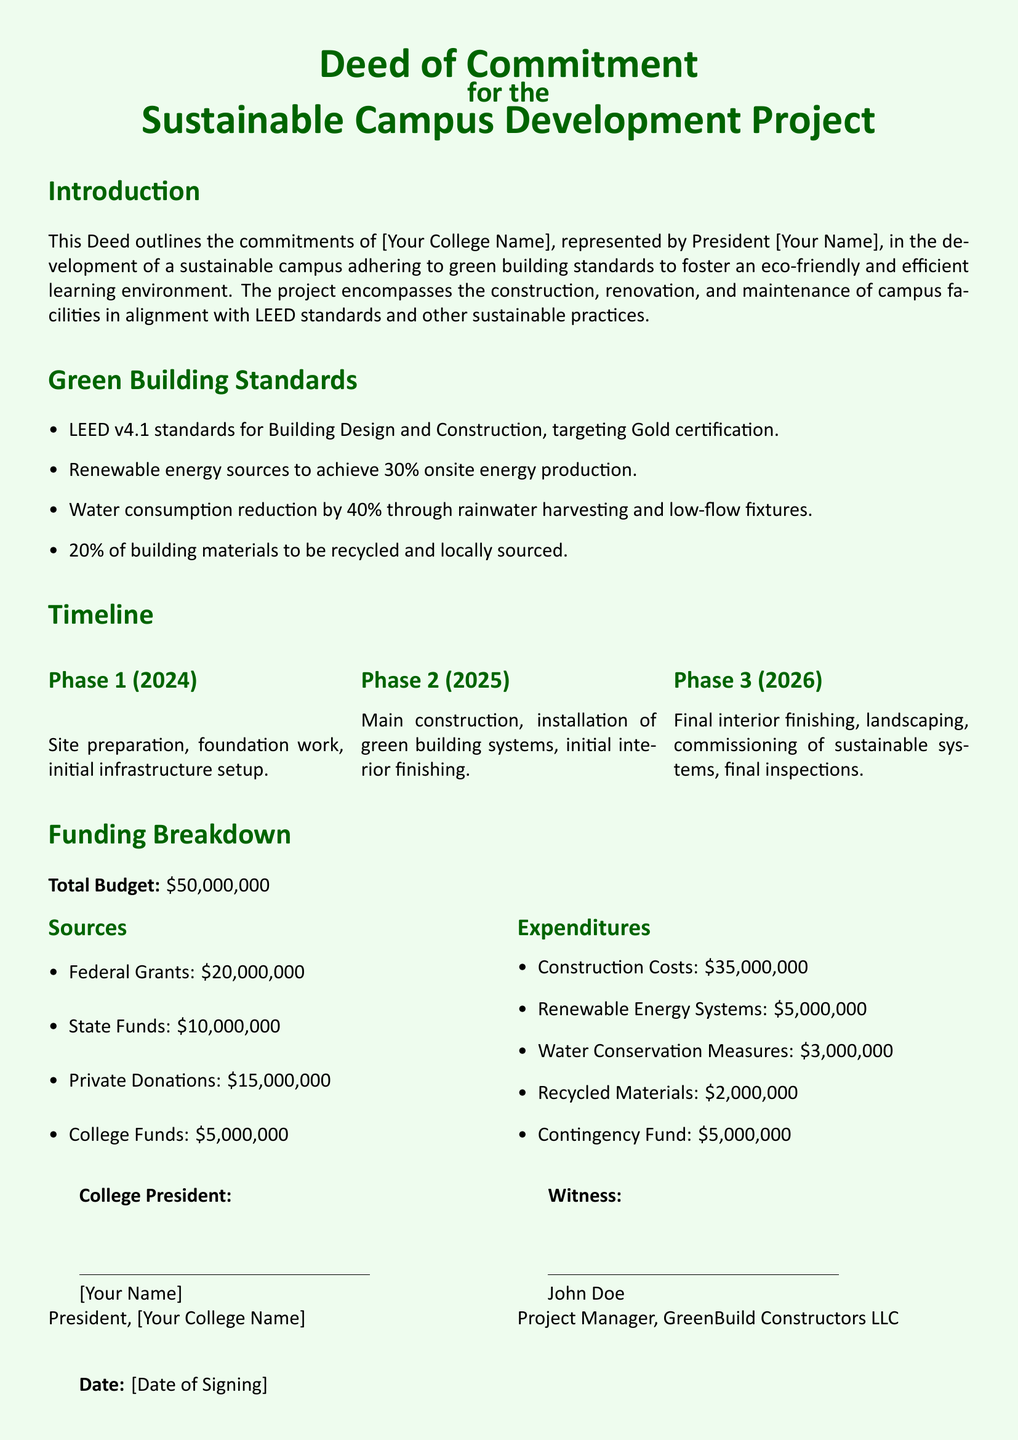What is the total budget for the project? The total budget is stated explicitly in the document as the overall funding required for the Sustainable Campus Development Project.
Answer: $50,000,000 What green building certification is targeted? The document specifies that the project aims to achieve a certain level of certification, reflecting its commitment to sustainable practices.
Answer: Gold certification What is the funding amount from federal grants? The document details the contributions from various funding sources, specifically stating how much will come from federal support.
Answer: $20,000,000 What year will Phase 1 begin? The timeline section indicates the year in which the initial phase of the construction project is set to start.
Answer: 2024 How much will be allocated for renewable energy systems? The expenditures section of the deed breaks down the budget into specific categories, outlining how much is dedicated to renewable energy initiatives.
Answer: $5,000,000 What percentage reduction in water consumption is targeted? The sustainable objectives outlined in the document convey specific goals for resource conservation, including water usage.
Answer: 40% Who is the project manager listed as a witness? The document includes the name of a person acting as a witness to the signing of the deed, indicating their role in the project.
Answer: John Doe What is the planned expenditure on recycled materials? The financial breakdown gives a clear indication of how much of the budget will be specifically allocated to incorporating sustainability in materials used.
Answer: $2,000,000 